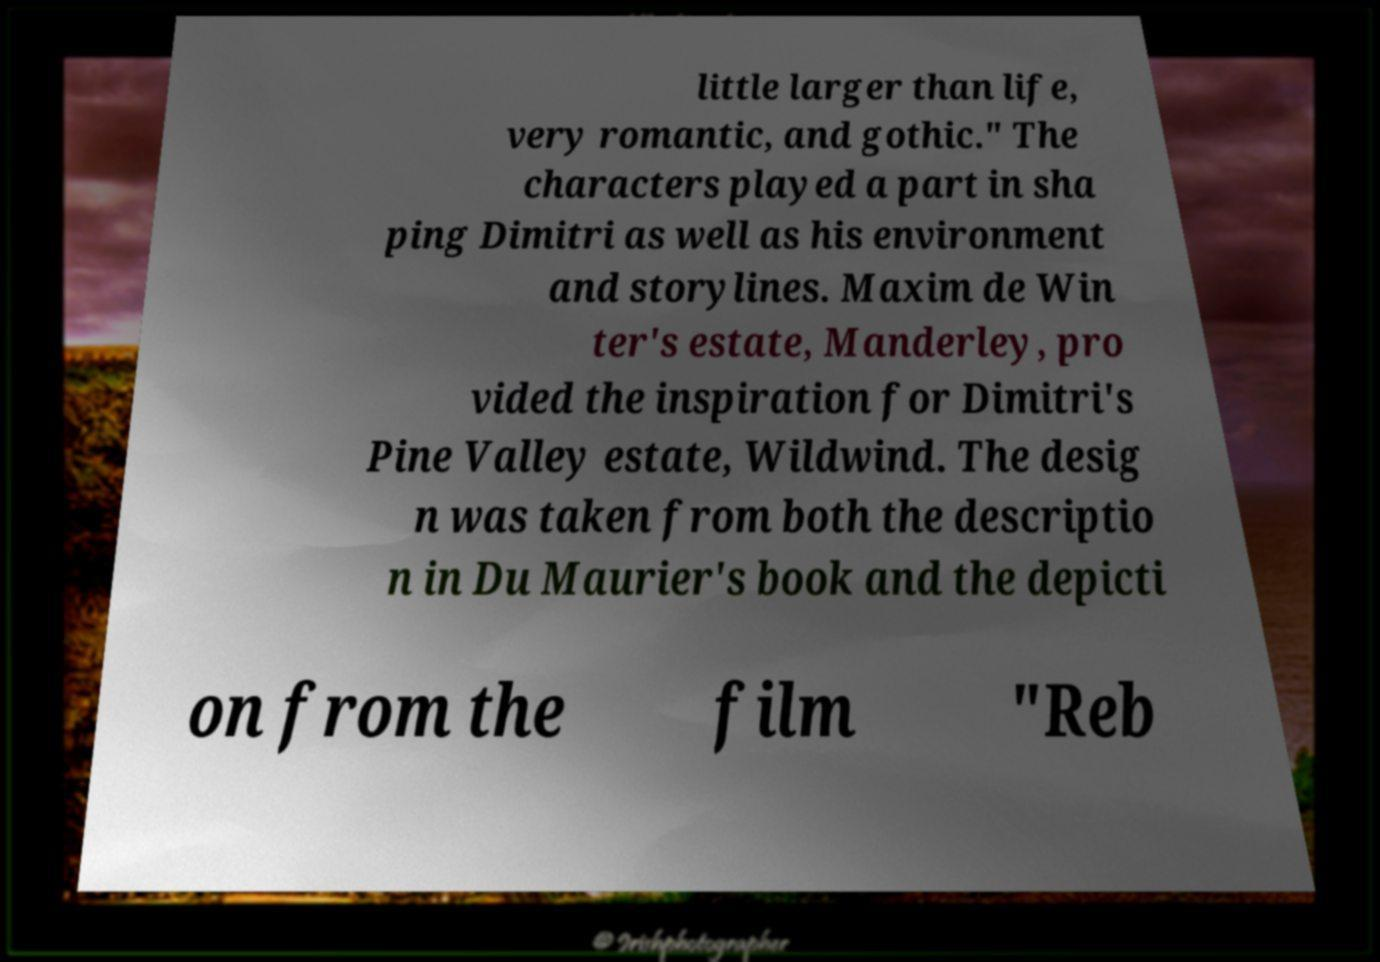Could you extract and type out the text from this image? little larger than life, very romantic, and gothic." The characters played a part in sha ping Dimitri as well as his environment and storylines. Maxim de Win ter's estate, Manderley, pro vided the inspiration for Dimitri's Pine Valley estate, Wildwind. The desig n was taken from both the descriptio n in Du Maurier's book and the depicti on from the film "Reb 